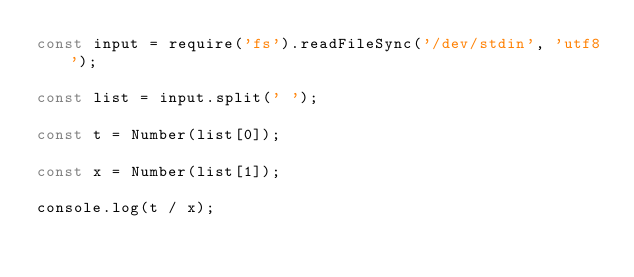Convert code to text. <code><loc_0><loc_0><loc_500><loc_500><_JavaScript_>const input = require('fs').readFileSync('/dev/stdin', 'utf8');

const list = input.split(' ');

const t = Number(list[0]);

const x = Number(list[1]);

console.log(t / x);
</code> 